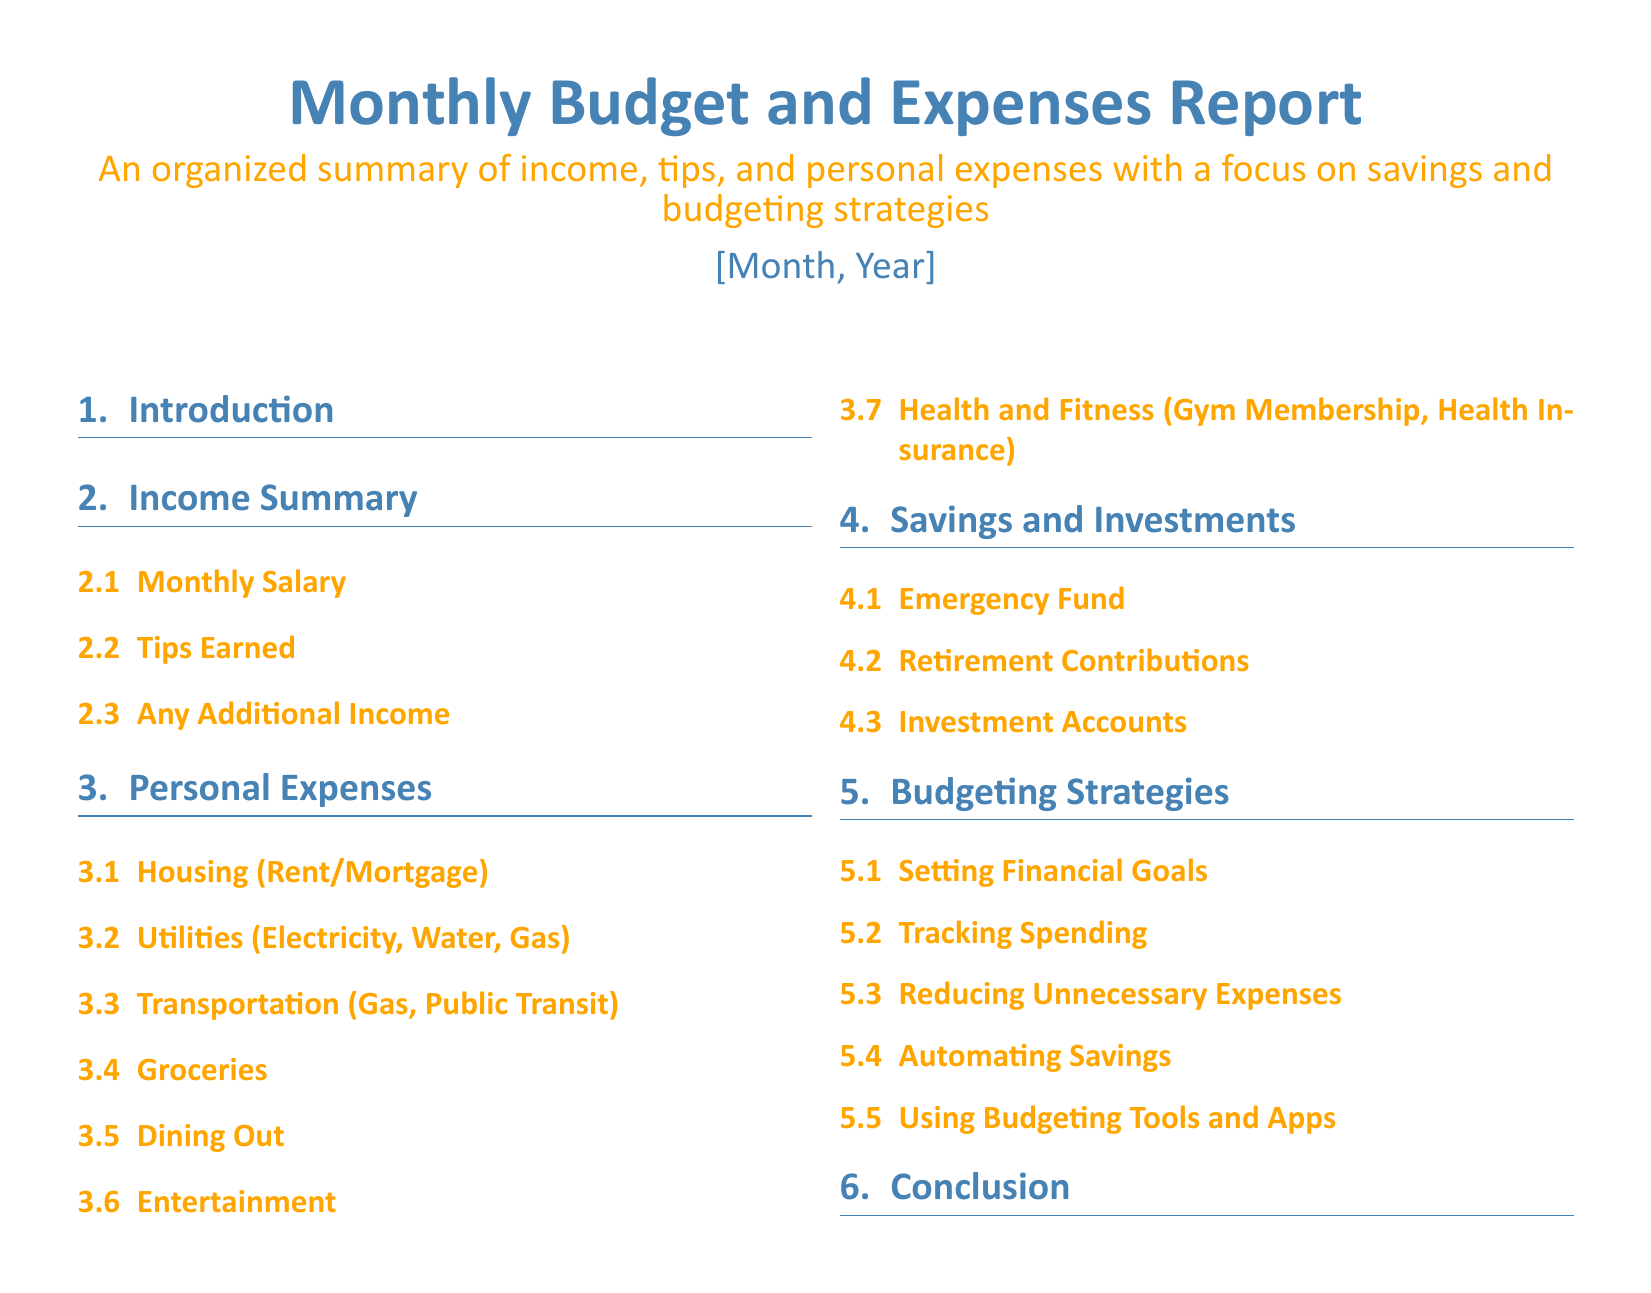what is the title of the document? The title of the document is prominently displayed at the top and summarizes its content.
Answer: Monthly Budget and Expenses Report what section outlines savings strategies? The section discusses various strategies for saving money and managing finances.
Answer: Budgeting Strategies how many subsections are under Personal Expenses? The subsections under Personal Expenses detail different types of expenditures for clarity.
Answer: 6 what is the focus of the Monthly Budget and Expenses Report? The document has a specific aim that is communicated in the subtitle.
Answer: Savings and budgeting strategies which financial goal is mentioned in the document? The document suggests specific financial strategies to achieve certain outcomes.
Answer: Setting Financial Goals what is one suggested way to track finances? The document offers methods to keep an overview of expenses and income.
Answer: Using Budgeting Tools and Apps what type of information is summarized in the Income Summary section? The section specifically summarizes the sources and amounts of income for clarity.
Answer: Monthly Salary, Tips Earned, Any Additional Income what is included in the Savings and Investments section? The section summarizes different types of savings and investment accounts.
Answer: Emergency Fund, Retirement Contributions, Investment Accounts how is the document organized? The organization of the document is reflected in the use of sections and subsections.
Answer: Multi-column format with sections and subsections 